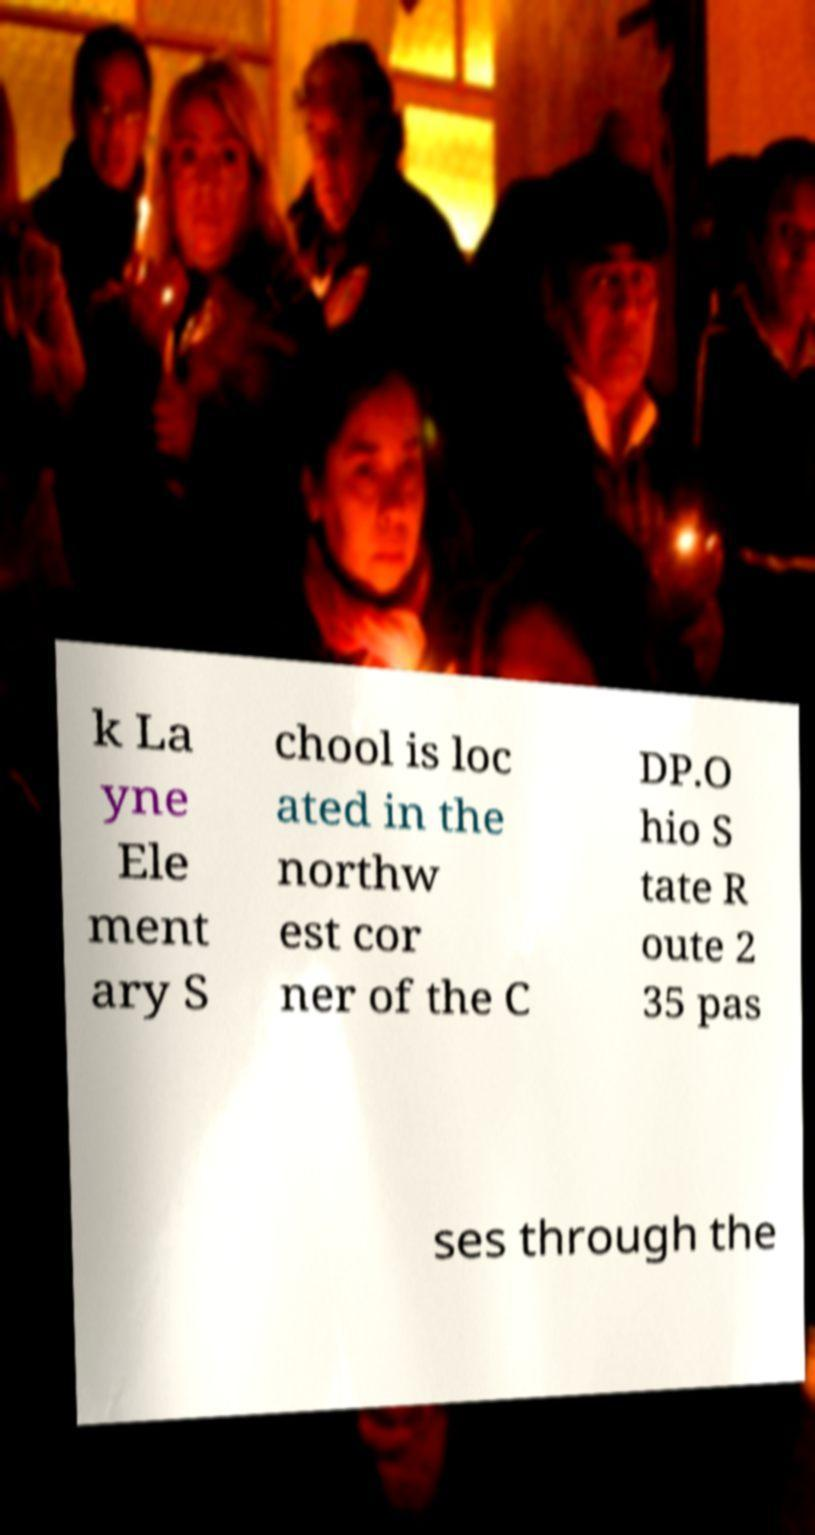Could you assist in decoding the text presented in this image and type it out clearly? k La yne Ele ment ary S chool is loc ated in the northw est cor ner of the C DP.O hio S tate R oute 2 35 pas ses through the 